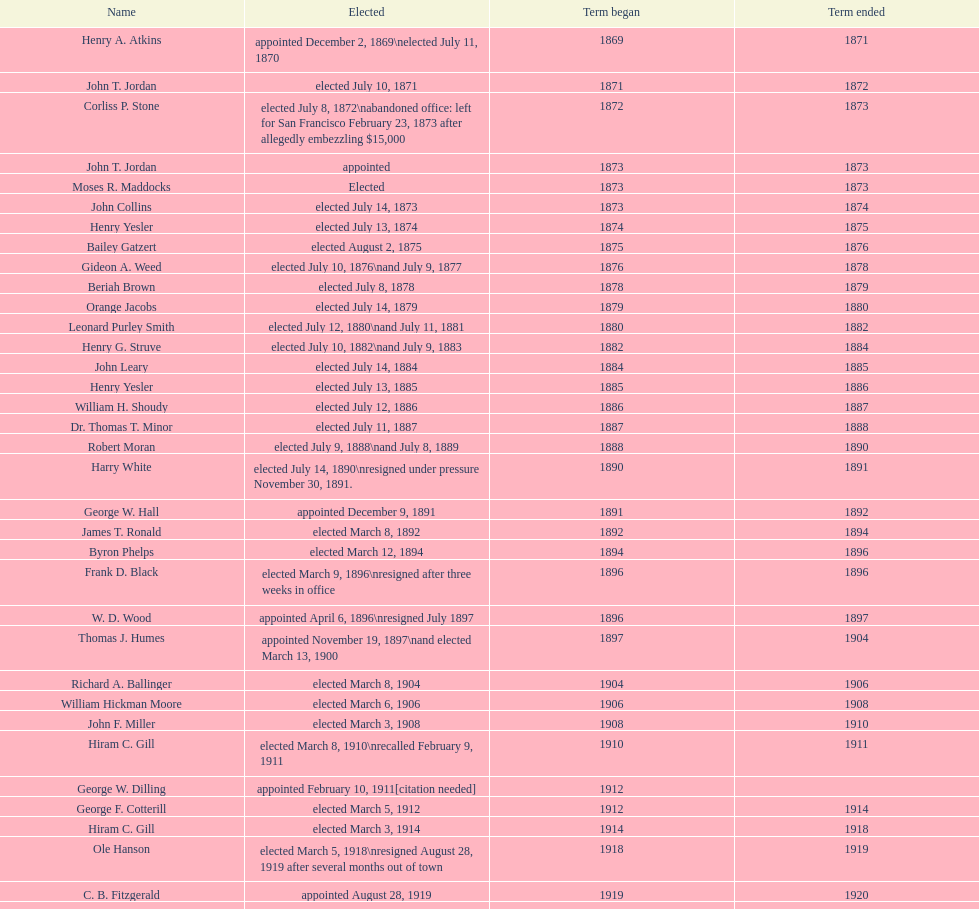How many women have been elected mayor of seattle, washington? 1. Parse the full table. {'header': ['Name', 'Elected', 'Term began', 'Term ended'], 'rows': [['Henry A. Atkins', 'appointed December 2, 1869\\nelected July 11, 1870', '1869', '1871'], ['John T. Jordan', 'elected July 10, 1871', '1871', '1872'], ['Corliss P. Stone', 'elected July 8, 1872\\nabandoned office: left for San Francisco February 23, 1873 after allegedly embezzling $15,000', '1872', '1873'], ['John T. Jordan', 'appointed', '1873', '1873'], ['Moses R. Maddocks', 'Elected', '1873', '1873'], ['John Collins', 'elected July 14, 1873', '1873', '1874'], ['Henry Yesler', 'elected July 13, 1874', '1874', '1875'], ['Bailey Gatzert', 'elected August 2, 1875', '1875', '1876'], ['Gideon A. Weed', 'elected July 10, 1876\\nand July 9, 1877', '1876', '1878'], ['Beriah Brown', 'elected July 8, 1878', '1878', '1879'], ['Orange Jacobs', 'elected July 14, 1879', '1879', '1880'], ['Leonard Purley Smith', 'elected July 12, 1880\\nand July 11, 1881', '1880', '1882'], ['Henry G. Struve', 'elected July 10, 1882\\nand July 9, 1883', '1882', '1884'], ['John Leary', 'elected July 14, 1884', '1884', '1885'], ['Henry Yesler', 'elected July 13, 1885', '1885', '1886'], ['William H. Shoudy', 'elected July 12, 1886', '1886', '1887'], ['Dr. Thomas T. Minor', 'elected July 11, 1887', '1887', '1888'], ['Robert Moran', 'elected July 9, 1888\\nand July 8, 1889', '1888', '1890'], ['Harry White', 'elected July 14, 1890\\nresigned under pressure November 30, 1891.', '1890', '1891'], ['George W. Hall', 'appointed December 9, 1891', '1891', '1892'], ['James T. Ronald', 'elected March 8, 1892', '1892', '1894'], ['Byron Phelps', 'elected March 12, 1894', '1894', '1896'], ['Frank D. Black', 'elected March 9, 1896\\nresigned after three weeks in office', '1896', '1896'], ['W. D. Wood', 'appointed April 6, 1896\\nresigned July 1897', '1896', '1897'], ['Thomas J. Humes', 'appointed November 19, 1897\\nand elected March 13, 1900', '1897', '1904'], ['Richard A. Ballinger', 'elected March 8, 1904', '1904', '1906'], ['William Hickman Moore', 'elected March 6, 1906', '1906', '1908'], ['John F. Miller', 'elected March 3, 1908', '1908', '1910'], ['Hiram C. Gill', 'elected March 8, 1910\\nrecalled February 9, 1911', '1910', '1911'], ['George W. Dilling', 'appointed February 10, 1911[citation needed]', '1912', ''], ['George F. Cotterill', 'elected March 5, 1912', '1912', '1914'], ['Hiram C. Gill', 'elected March 3, 1914', '1914', '1918'], ['Ole Hanson', 'elected March 5, 1918\\nresigned August 28, 1919 after several months out of town', '1918', '1919'], ['C. B. Fitzgerald', 'appointed August 28, 1919', '1919', '1920'], ['Hugh M. Caldwell', 'elected March 2, 1920', '1920', '1922'], ['Edwin J. Brown', 'elected May 2, 1922\\nand March 4, 1924', '1922', '1926'], ['Bertha Knight Landes', 'elected March 9, 1926', '1926', '1928'], ['Frank E. Edwards', 'elected March 6, 1928\\nand March 4, 1930\\nrecalled July 13, 1931', '1928', '1931'], ['Robert H. Harlin', 'appointed July 14, 1931', '1931', '1932'], ['John F. Dore', 'elected March 8, 1932', '1932', '1934'], ['Charles L. Smith', 'elected March 6, 1934', '1934', '1936'], ['John F. Dore', 'elected March 3, 1936\\nbecame gravely ill and was relieved of office April 13, 1938, already a lame duck after the 1938 election. He died five days later.', '1936', '1938'], ['Arthur B. Langlie', "elected March 8, 1938\\nappointed to take office early, April 27, 1938, after Dore's death.\\nelected March 5, 1940\\nresigned January 11, 1941, to become Governor of Washington", '1938', '1941'], ['John E. Carroll', 'appointed January 27, 1941', '1941', '1941'], ['Earl Millikin', 'elected March 4, 1941', '1941', '1942'], ['William F. Devin', 'elected March 3, 1942, March 7, 1944, March 5, 1946, and March 2, 1948', '1942', '1952'], ['Allan Pomeroy', 'elected March 4, 1952', '1952', '1956'], ['Gordon S. Clinton', 'elected March 6, 1956\\nand March 8, 1960', '1956', '1964'], ["James d'Orma Braman", 'elected March 10, 1964\\nresigned March 23, 1969, to accept an appointment as an Assistant Secretary in the Department of Transportation in the Nixon administration.', '1964', '1969'], ['Floyd C. Miller', 'appointed March 23, 1969', '1969', '1969'], ['Wesley C. Uhlman', 'elected November 4, 1969\\nand November 6, 1973\\nsurvived recall attempt on July 1, 1975', 'December 1, 1969', 'January 1, 1978'], ['Charles Royer', 'elected November 8, 1977, November 3, 1981, and November 5, 1985', 'January 1, 1978', 'January 1, 1990'], ['Norman B. Rice', 'elected November 7, 1989', 'January 1, 1990', 'January 1, 1998'], ['Paul Schell', 'elected November 4, 1997', 'January 1, 1998', 'January 1, 2002'], ['Gregory J. Nickels', 'elected November 6, 2001\\nand November 8, 2005', 'January 1, 2002', 'January 1, 2010'], ['Michael McGinn', 'elected November 3, 2009', 'January 1, 2010', 'January 1, 2014'], ['Ed Murray', 'elected November 5, 2013', 'January 1, 2014', 'present']]} 